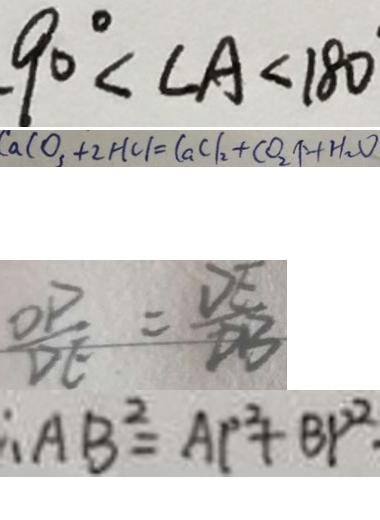Convert formula to latex. <formula><loc_0><loc_0><loc_500><loc_500>9 0 ^ { \circ } < \angle A < 1 8 0 
 C a C O _ { 3 } + 2 H C l = C a C l _ { 2 } + C O _ { 2 } \uparrow + H _ { 2 } O 
 \frac { O P } { D E } = \frac { D E } { D B } 
 \therefore A B ^ { 2 } = A P ^ { 2 } + B P ^ { 2 } .</formula> 